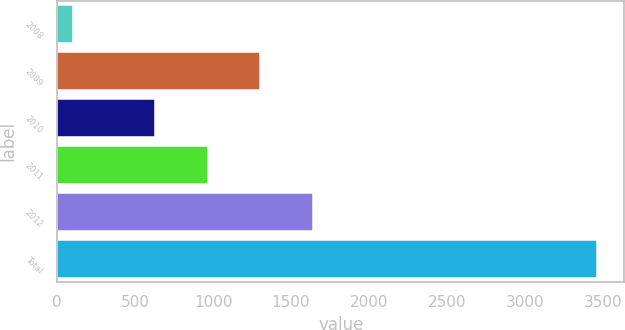Convert chart to OTSL. <chart><loc_0><loc_0><loc_500><loc_500><bar_chart><fcel>2008<fcel>2009<fcel>2010<fcel>2011<fcel>2012<fcel>Total<nl><fcel>101<fcel>1302.8<fcel>630<fcel>966.4<fcel>1639.2<fcel>3465<nl></chart> 